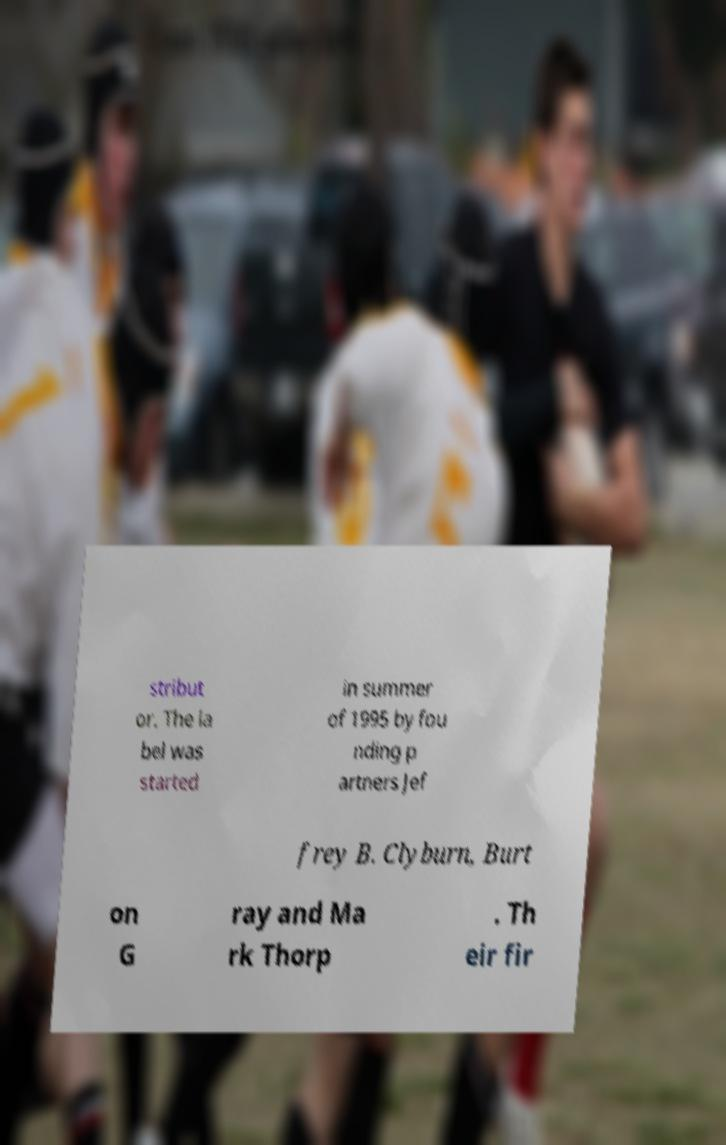Can you read and provide the text displayed in the image?This photo seems to have some interesting text. Can you extract and type it out for me? stribut or. The la bel was started in summer of 1995 by fou nding p artners Jef frey B. Clyburn, Burt on G ray and Ma rk Thorp . Th eir fir 